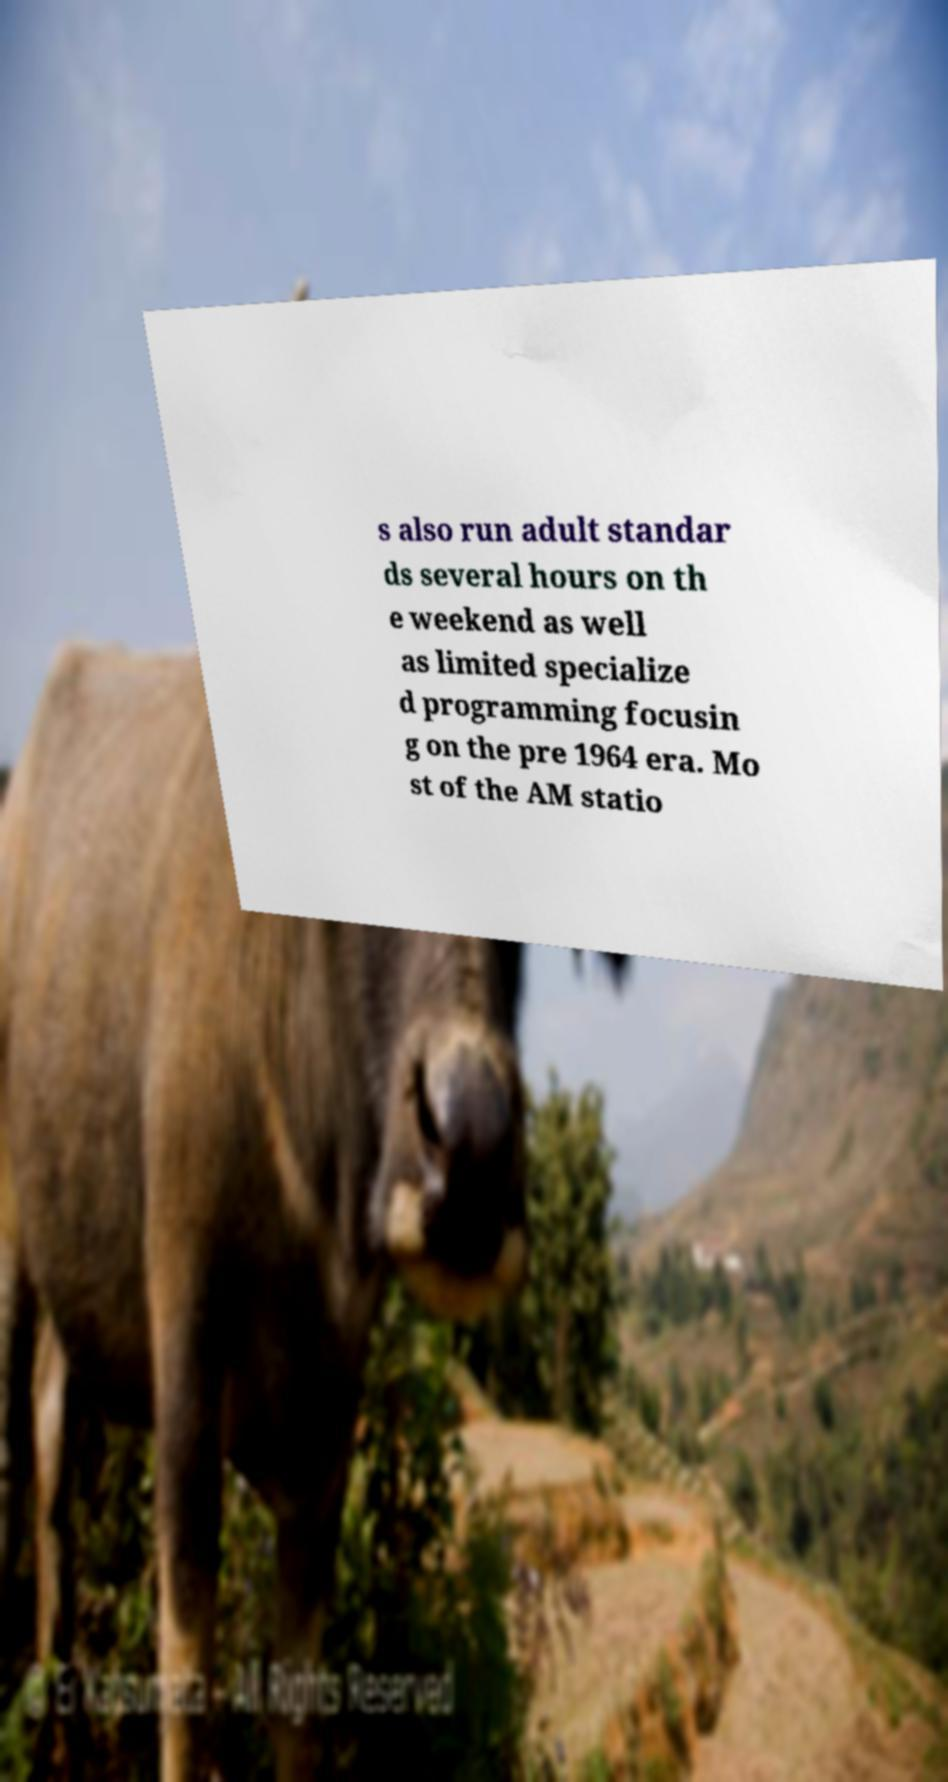I need the written content from this picture converted into text. Can you do that? s also run adult standar ds several hours on th e weekend as well as limited specialize d programming focusin g on the pre 1964 era. Mo st of the AM statio 